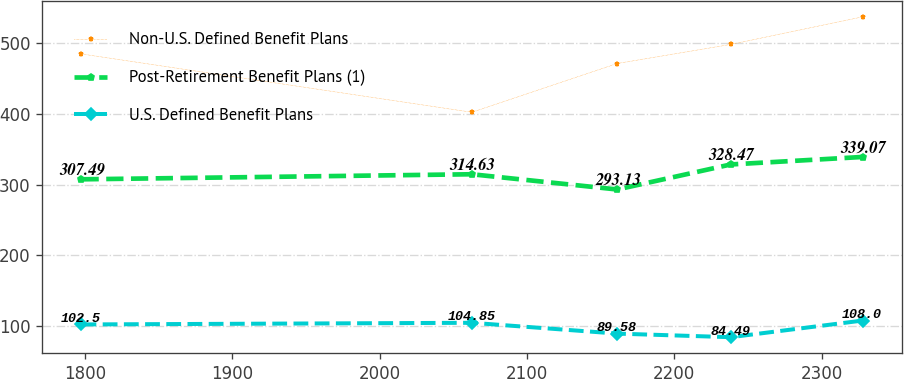Convert chart. <chart><loc_0><loc_0><loc_500><loc_500><line_chart><ecel><fcel>Non-U.S. Defined Benefit Plans<fcel>Post-Retirement Benefit Plans (1)<fcel>U.S. Defined Benefit Plans<nl><fcel>1797.7<fcel>484.54<fcel>307.49<fcel>102.5<nl><fcel>2062.6<fcel>402.19<fcel>314.63<fcel>104.85<nl><fcel>2161.24<fcel>471.06<fcel>293.13<fcel>89.58<nl><fcel>2238.27<fcel>498.02<fcel>328.47<fcel>84.49<nl><fcel>2327.7<fcel>536.97<fcel>339.07<fcel>108<nl></chart> 